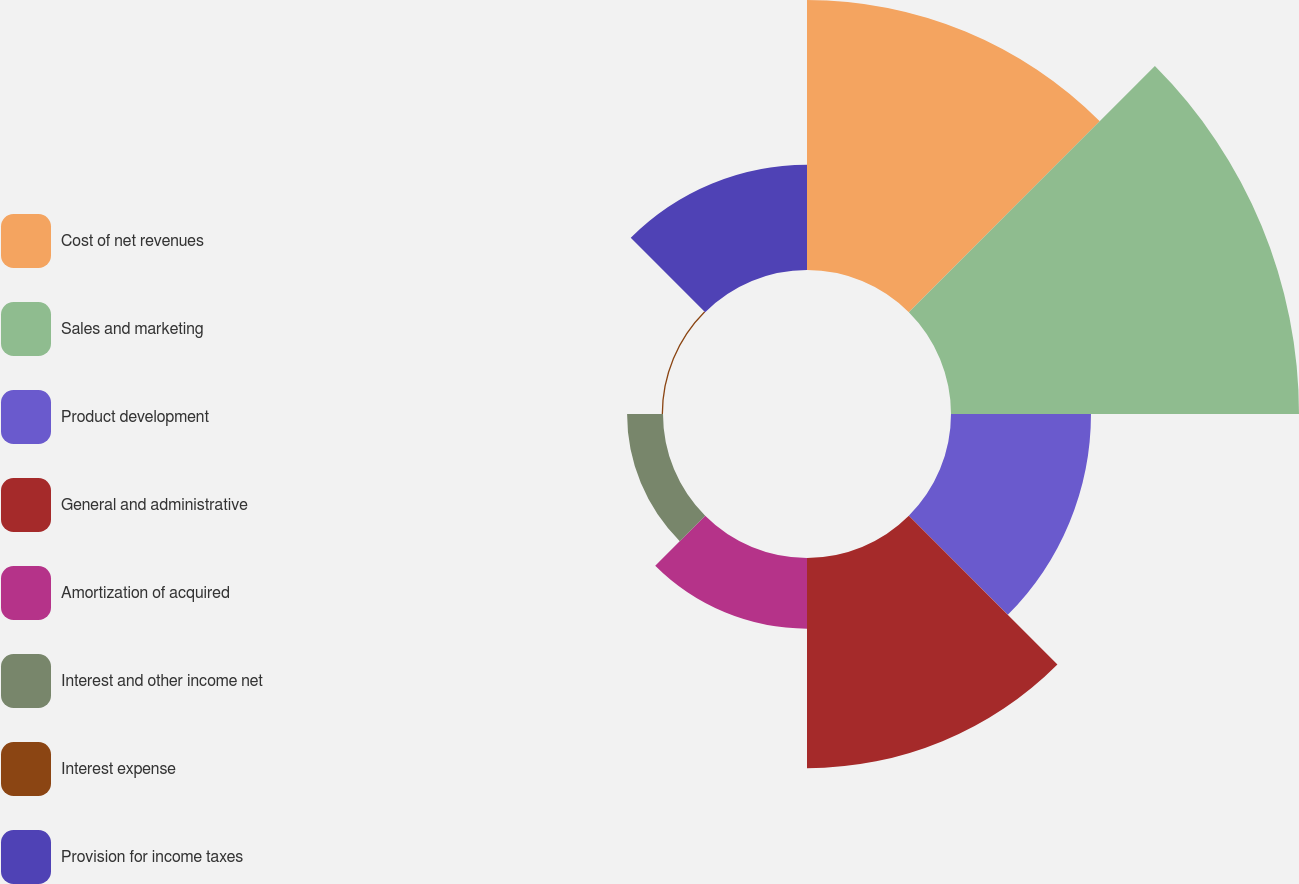Convert chart to OTSL. <chart><loc_0><loc_0><loc_500><loc_500><pie_chart><fcel>Cost of net revenues<fcel>Sales and marketing<fcel>Product development<fcel>General and administrative<fcel>Amortization of acquired<fcel>Interest and other income net<fcel>Interest expense<fcel>Provision for income taxes<nl><fcel>22.86%<fcel>29.46%<fcel>11.85%<fcel>17.79%<fcel>5.98%<fcel>3.04%<fcel>0.11%<fcel>8.91%<nl></chart> 